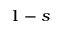<formula> <loc_0><loc_0><loc_500><loc_500>1 - s</formula> 